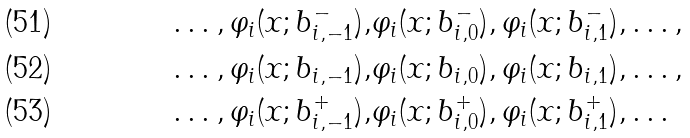<formula> <loc_0><loc_0><loc_500><loc_500>\dots , \varphi _ { i } ( x ; b ^ { - } _ { i , - 1 } ) , & \varphi _ { i } ( x ; b ^ { - } _ { i , 0 } ) , \varphi _ { i } ( x ; b ^ { - } _ { i , 1 } ) , \dots , \\ \dots , \varphi _ { i } ( x ; b _ { i , - 1 } ) , & \varphi _ { i } ( x ; b _ { i , 0 } ) , \varphi _ { i } ( x ; b _ { i , 1 } ) , \dots , \\ \dots , \varphi _ { i } ( x ; b ^ { + } _ { i , - 1 } ) , & \varphi _ { i } ( x ; b ^ { + } _ { i , 0 } ) , \varphi _ { i } ( x ; b ^ { + } _ { i , 1 } ) , \dots</formula> 